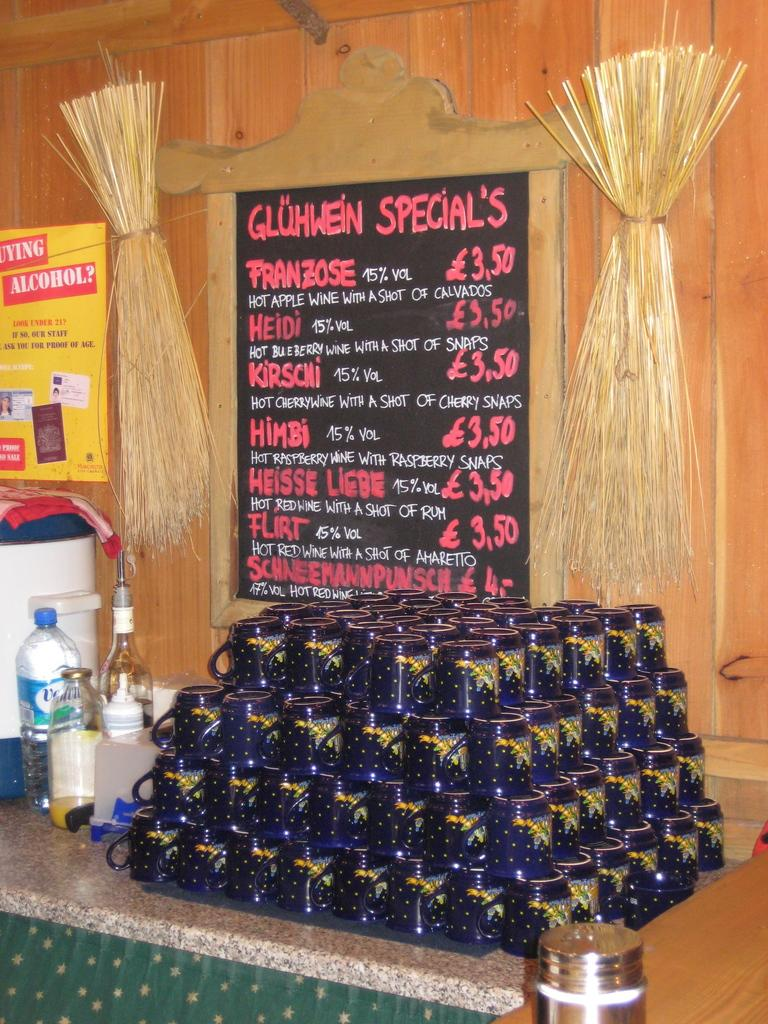<image>
Summarize the visual content of the image. A pyramid of coffee cups under a menu sign that says Gluhwein Special's. 